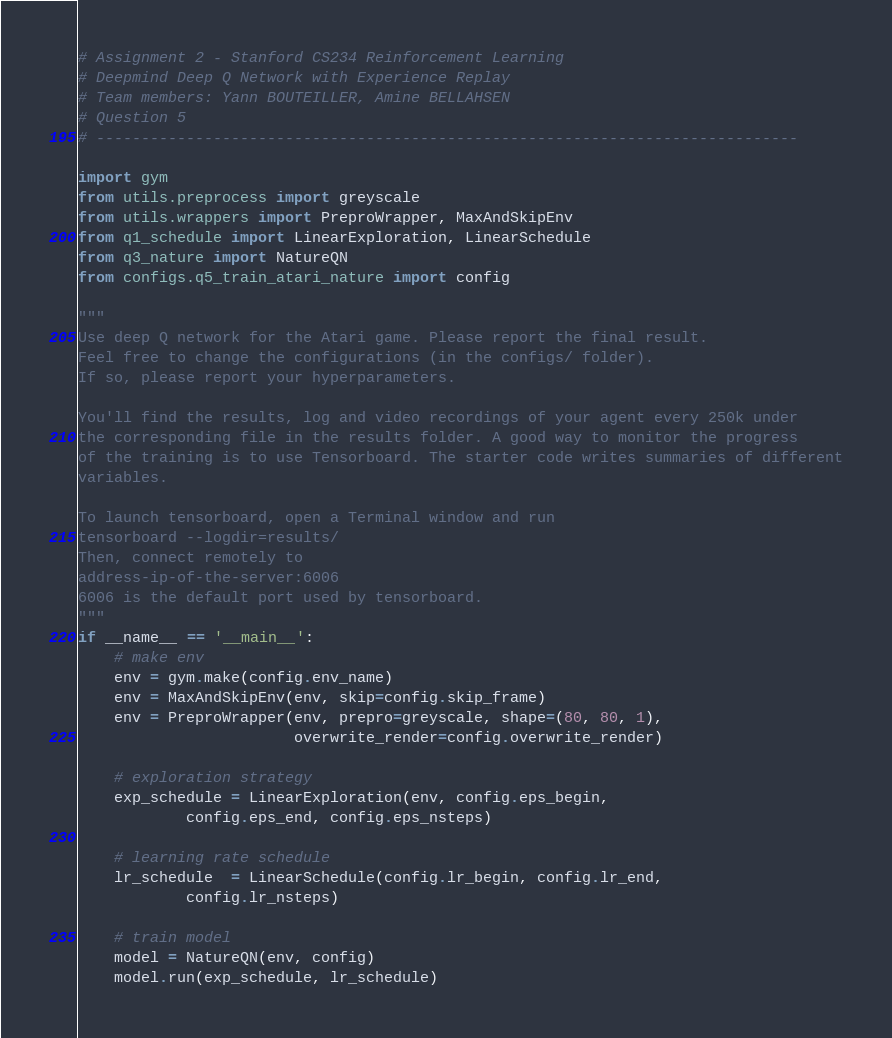<code> <loc_0><loc_0><loc_500><loc_500><_Python_># Assignment 2 - Stanford CS234 Reinforcement Learning
# Deepmind Deep Q Network with Experience Replay
# Team members: Yann BOUTEILLER, Amine BELLAHSEN
# Question 5
# ------------------------------------------------------------------------------

import gym
from utils.preprocess import greyscale
from utils.wrappers import PreproWrapper, MaxAndSkipEnv
from q1_schedule import LinearExploration, LinearSchedule
from q3_nature import NatureQN
from configs.q5_train_atari_nature import config

"""
Use deep Q network for the Atari game. Please report the final result.
Feel free to change the configurations (in the configs/ folder).
If so, please report your hyperparameters.

You'll find the results, log and video recordings of your agent every 250k under
the corresponding file in the results folder. A good way to monitor the progress
of the training is to use Tensorboard. The starter code writes summaries of different
variables.

To launch tensorboard, open a Terminal window and run
tensorboard --logdir=results/
Then, connect remotely to
address-ip-of-the-server:6006
6006 is the default port used by tensorboard.
"""
if __name__ == '__main__':
    # make env
    env = gym.make(config.env_name)
    env = MaxAndSkipEnv(env, skip=config.skip_frame)
    env = PreproWrapper(env, prepro=greyscale, shape=(80, 80, 1),
                        overwrite_render=config.overwrite_render)

    # exploration strategy
    exp_schedule = LinearExploration(env, config.eps_begin,
            config.eps_end, config.eps_nsteps)

    # learning rate schedule
    lr_schedule  = LinearSchedule(config.lr_begin, config.lr_end,
            config.lr_nsteps)

    # train model
    model = NatureQN(env, config)
    model.run(exp_schedule, lr_schedule)
</code> 